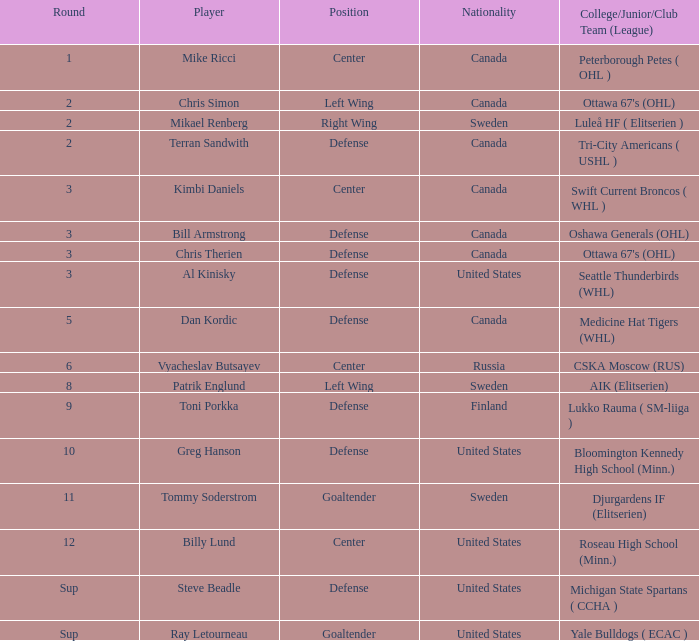What player is playing on round 1 Mike Ricci. 